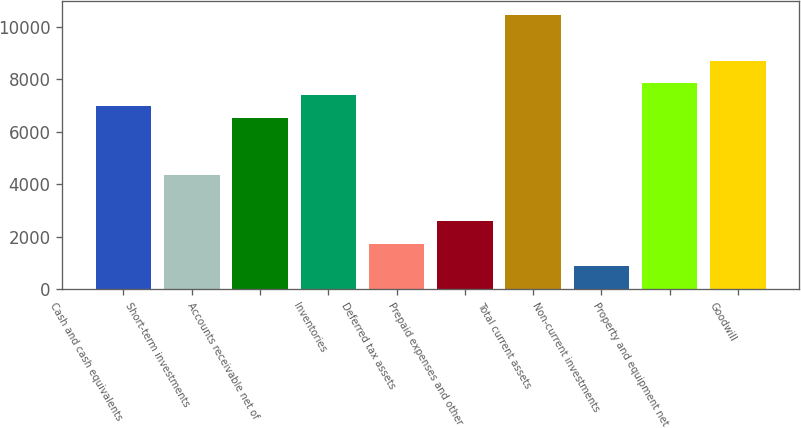Convert chart. <chart><loc_0><loc_0><loc_500><loc_500><bar_chart><fcel>Cash and cash equivalents<fcel>Short-term investments<fcel>Accounts receivable net of<fcel>Inventories<fcel>Deferred tax assets<fcel>Prepaid expenses and other<fcel>Total current assets<fcel>Non-current investments<fcel>Property and equipment net<fcel>Goodwill<nl><fcel>6970.16<fcel>4356.5<fcel>6534.55<fcel>7405.77<fcel>1742.84<fcel>2614.06<fcel>10455<fcel>871.62<fcel>7841.38<fcel>8712.6<nl></chart> 